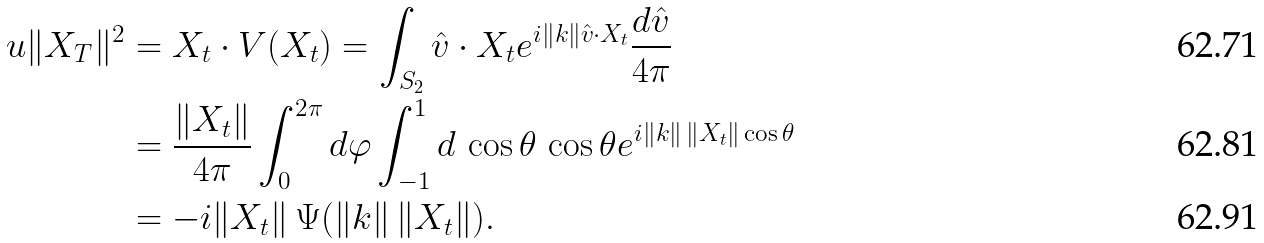Convert formula to latex. <formula><loc_0><loc_0><loc_500><loc_500>u \| X _ { T } \| ^ { 2 } & = X _ { t } \cdot V ( X _ { t } ) = \int _ { S _ { 2 } } \hat { v } \cdot X _ { t } e ^ { i \| k \| \hat { v } \cdot X _ { t } } \frac { d \hat { v } } { 4 \pi } \\ & = \frac { \| X _ { t } \| } { 4 \pi } \int _ { 0 } ^ { 2 \pi } d \varphi \int _ { - 1 } ^ { 1 } d \, \cos \theta \, \cos \theta e ^ { i \| k \| \, \| X _ { t } \| \cos \theta } \\ & = - i \| X _ { t } \| \, \Psi ( \| k \| \, \| X _ { t } \| ) .</formula> 